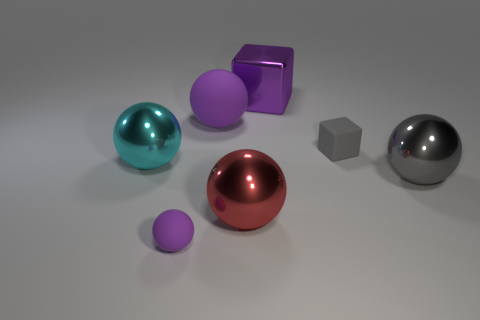Subtract all purple balls. How many balls are left? 3 Subtract all gray blocks. How many blocks are left? 1 Subtract 4 spheres. How many spheres are left? 1 Add 3 red metallic cylinders. How many objects exist? 10 Subtract all balls. How many objects are left? 2 Subtract all yellow blocks. Subtract all yellow cylinders. How many blocks are left? 2 Subtract all purple cylinders. How many purple cubes are left? 1 Subtract all large purple matte objects. Subtract all tiny matte spheres. How many objects are left? 5 Add 4 purple cubes. How many purple cubes are left? 5 Add 6 big yellow matte cylinders. How many big yellow matte cylinders exist? 6 